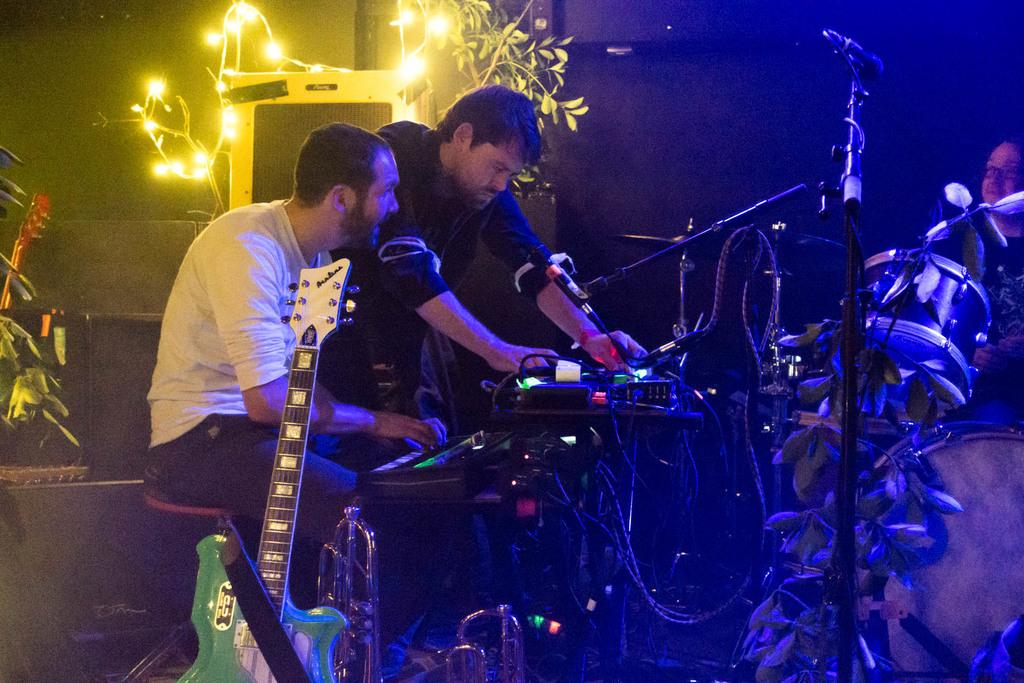Who or what can be seen in the image? There are people in the image. What musical instruments are present in the image? There is a guitar and a drum set in the image. What equipment might be used for amplifying sound in the image? There are microphones in the image. What can be seen in the background of the image? There are plants and lights in the background of the image. What type of camera can be seen in the image? There is no camera present in the image. What is the company logo on the drum set in the image? There is no company logo mentioned on the drum set in the image, and the image does not provide enough detail to determine the brand or model of the drum set. 